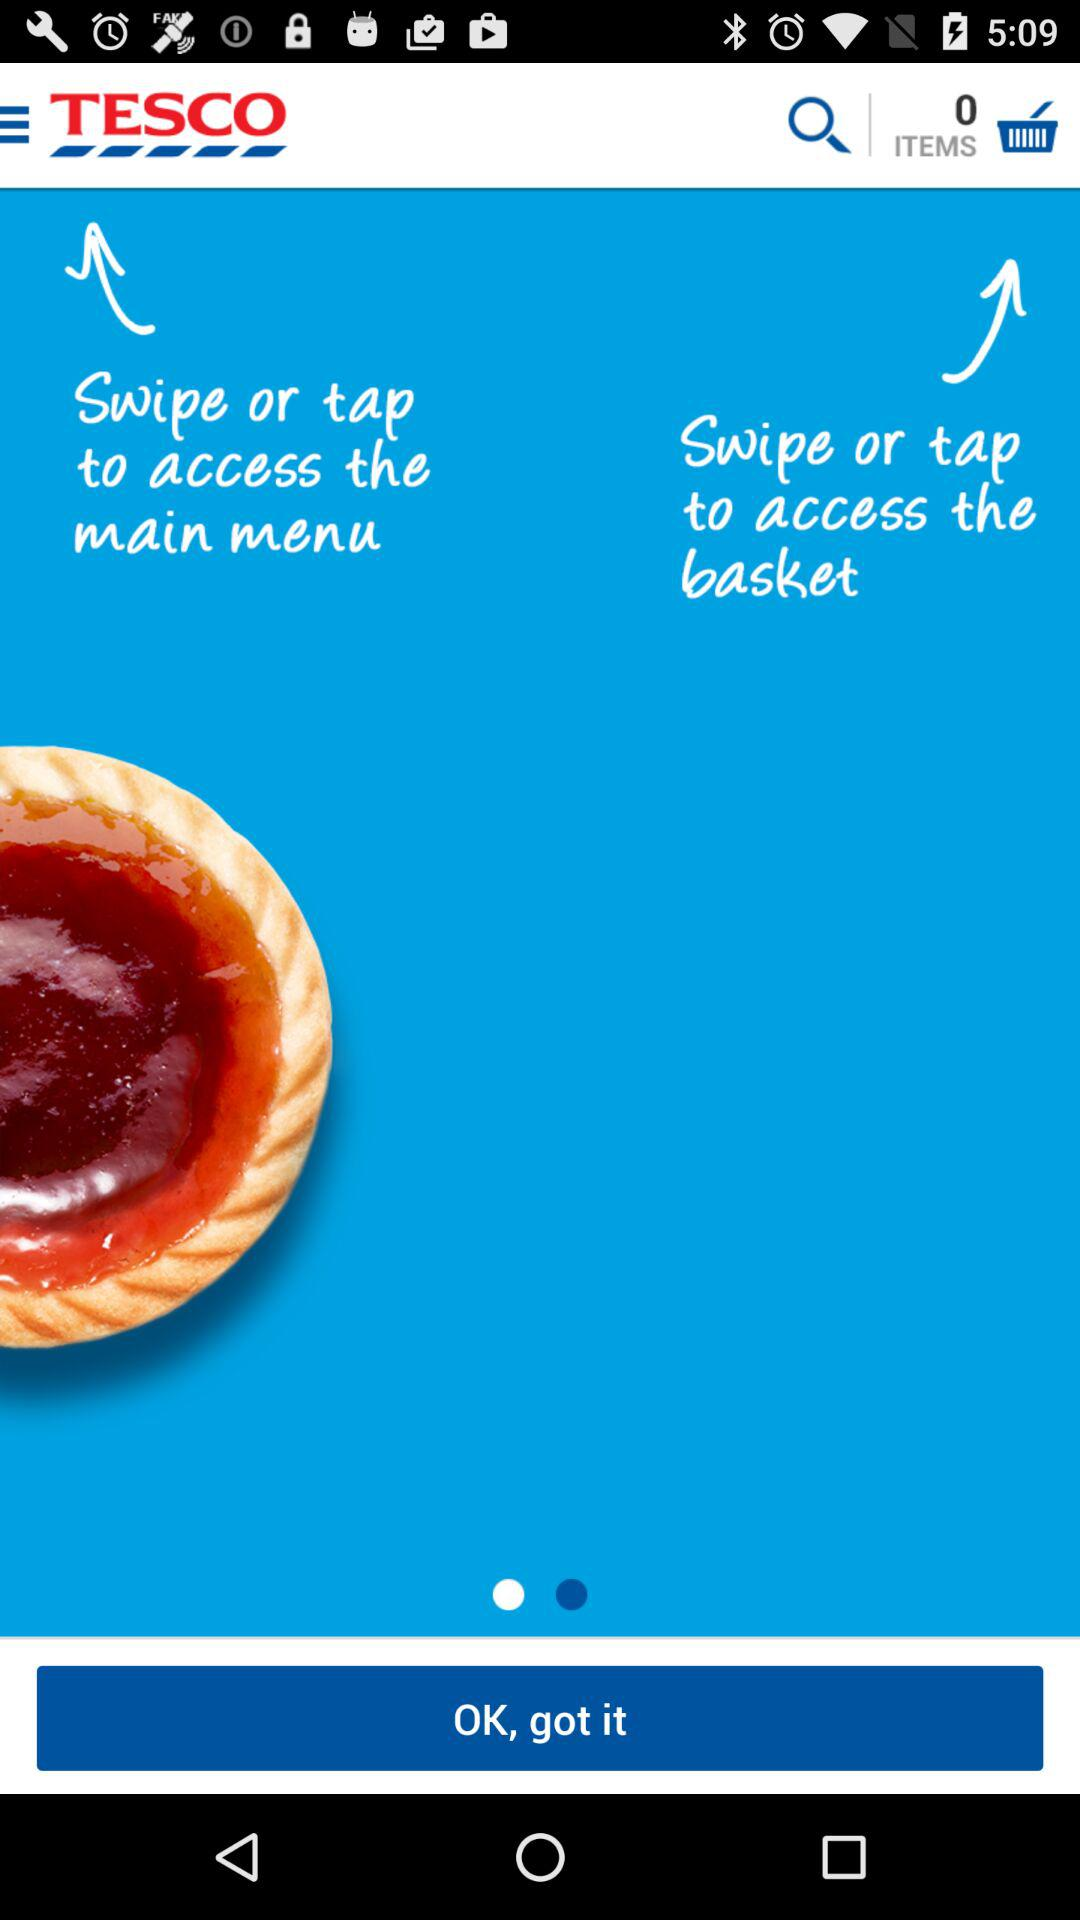How many items are there in the cart? There are 0 items in the cart. 